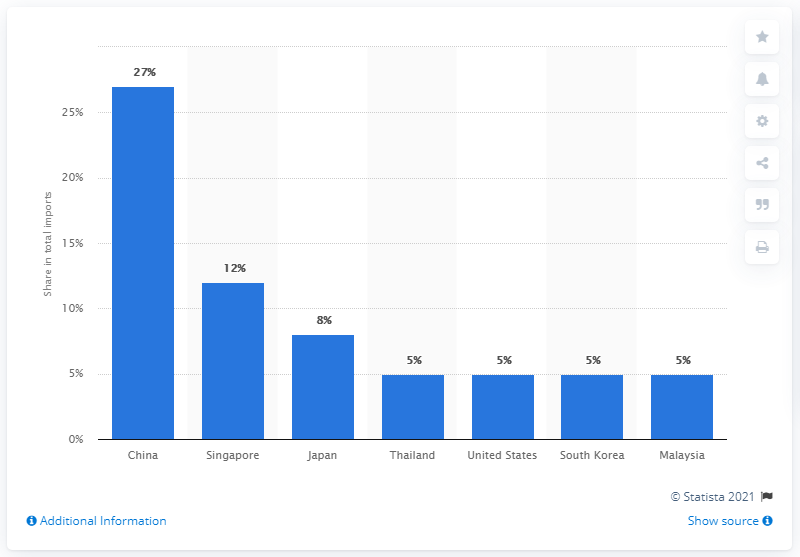Specify some key components in this picture. In 2019, Indonesia's most significant import partner was China. 